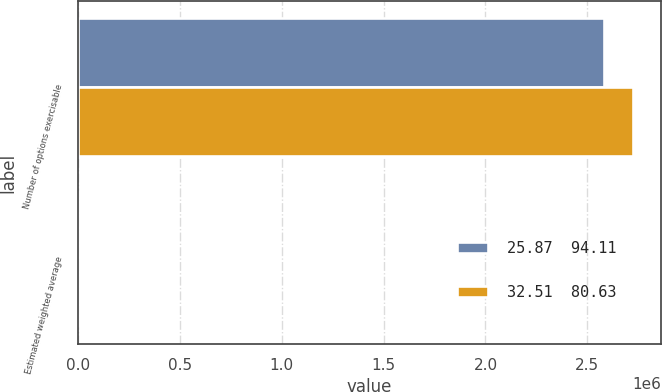Convert chart to OTSL. <chart><loc_0><loc_0><loc_500><loc_500><stacked_bar_chart><ecel><fcel>Number of options exercisable<fcel>Estimated weighted average<nl><fcel>25.87  94.11<fcel>2.58142e+06<fcel>12.8<nl><fcel>32.51  80.63<fcel>2.72598e+06<fcel>19.04<nl></chart> 